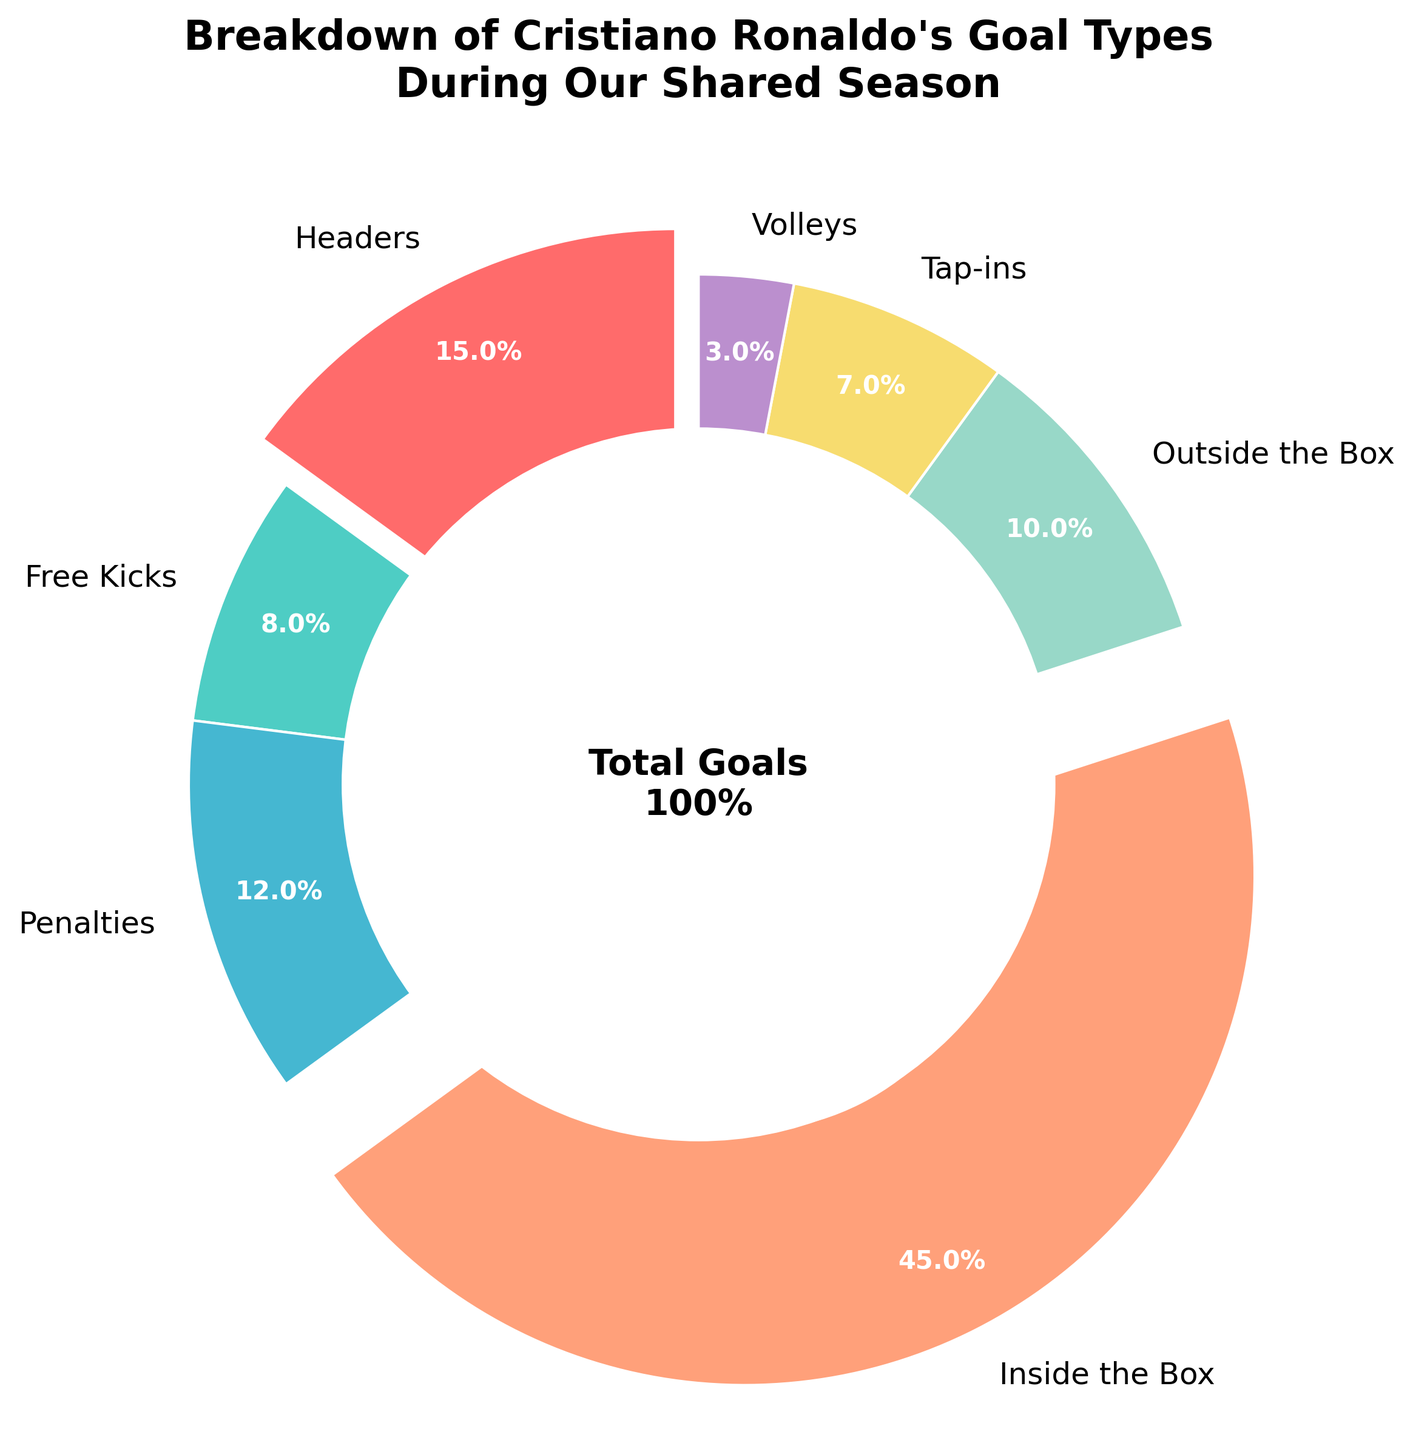Which goal type did Cristiano Ronaldo score the most? The goal type with the largest slice in the pie chart represents the highest scoring type. "Inside the Box" has the largest slice, accounting for 45%.
Answer: Inside the Box How many percent more goals did Cristiano Ronaldo score from headers compared to penalties? Headers account for 15% and penalties account for 12%. The difference between headers and penalties is 15% - 12% = 3%.
Answer: 3% Which two goal types combined make up exactly 15% of Cristiano Ronaldo's goals during our shared season? By examining the smaller slices, "Tap-ins" (7%) and "Volleys" (3%) combined make up 10%, thus the correct combination is "Free Kicks" (8%) and "Tap-ins" (7%) which together total 15%.
Answer: Free Kicks and Tap-ins Which goal type has a larger percentage: outside the box or free kicks? The pie chart shows that "Outside the Box" has 10% and "Free Kicks" has 8%. Since 10% > 8%, "Outside the Box" has a larger percentage.
Answer: Outside the Box By what factor is the percentage of goals inside the box greater than the percentage of goals from free kicks? Goals inside the box are 45%, while free kicks are 8%. The factor is calculated by 45 / 8 = 5.625.
Answer: 5.625 How much more did the "Inside the Box" goals contribute compared to all other types of goals combined? "Inside the Box" goals are 45%. Adding up all other percentages: Headers (15%) + Free Kicks (8%) + Penalties (12%) + Outside the Box (10%) + Tap-ins (7%) + Volleys (3%) equals 55%. The difference is 55% - 45% = 10%.
Answer: 10% What is the sum of the percentages for Headers, Penalties, and Tap-ins? Summing Headers (15%), Penalties (12%), and Tap-ins (7%) results in 15 + 12 + 7 = 34.
Answer: 34 